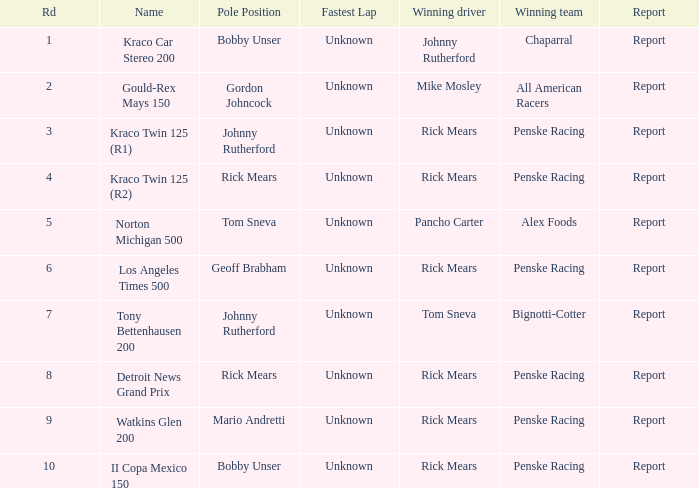How many winning drivers in the kraco twin 125 (r2) race were there? 1.0. 